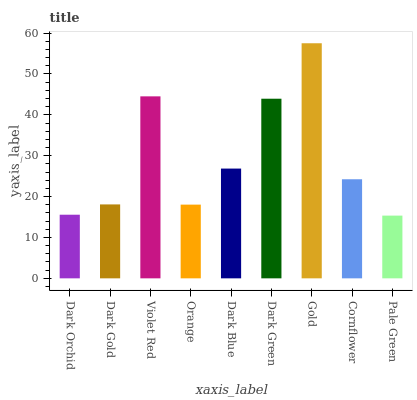Is Pale Green the minimum?
Answer yes or no. Yes. Is Gold the maximum?
Answer yes or no. Yes. Is Dark Gold the minimum?
Answer yes or no. No. Is Dark Gold the maximum?
Answer yes or no. No. Is Dark Gold greater than Dark Orchid?
Answer yes or no. Yes. Is Dark Orchid less than Dark Gold?
Answer yes or no. Yes. Is Dark Orchid greater than Dark Gold?
Answer yes or no. No. Is Dark Gold less than Dark Orchid?
Answer yes or no. No. Is Cornflower the high median?
Answer yes or no. Yes. Is Cornflower the low median?
Answer yes or no. Yes. Is Pale Green the high median?
Answer yes or no. No. Is Dark Blue the low median?
Answer yes or no. No. 